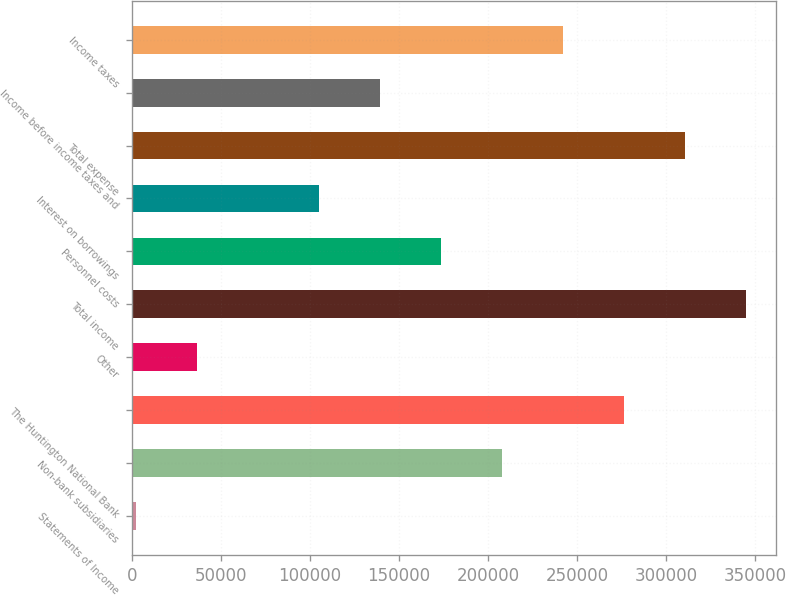Convert chart to OTSL. <chart><loc_0><loc_0><loc_500><loc_500><bar_chart><fcel>Statements of Income<fcel>Non-bank subsidiaries<fcel>The Huntington National Bank<fcel>Other<fcel>Total income<fcel>Personnel costs<fcel>Interest on borrowings<fcel>Total expense<fcel>Income before income taxes and<fcel>Income taxes<nl><fcel>2010<fcel>207781<fcel>276371<fcel>36305.1<fcel>344961<fcel>173486<fcel>104895<fcel>310666<fcel>139190<fcel>242076<nl></chart> 